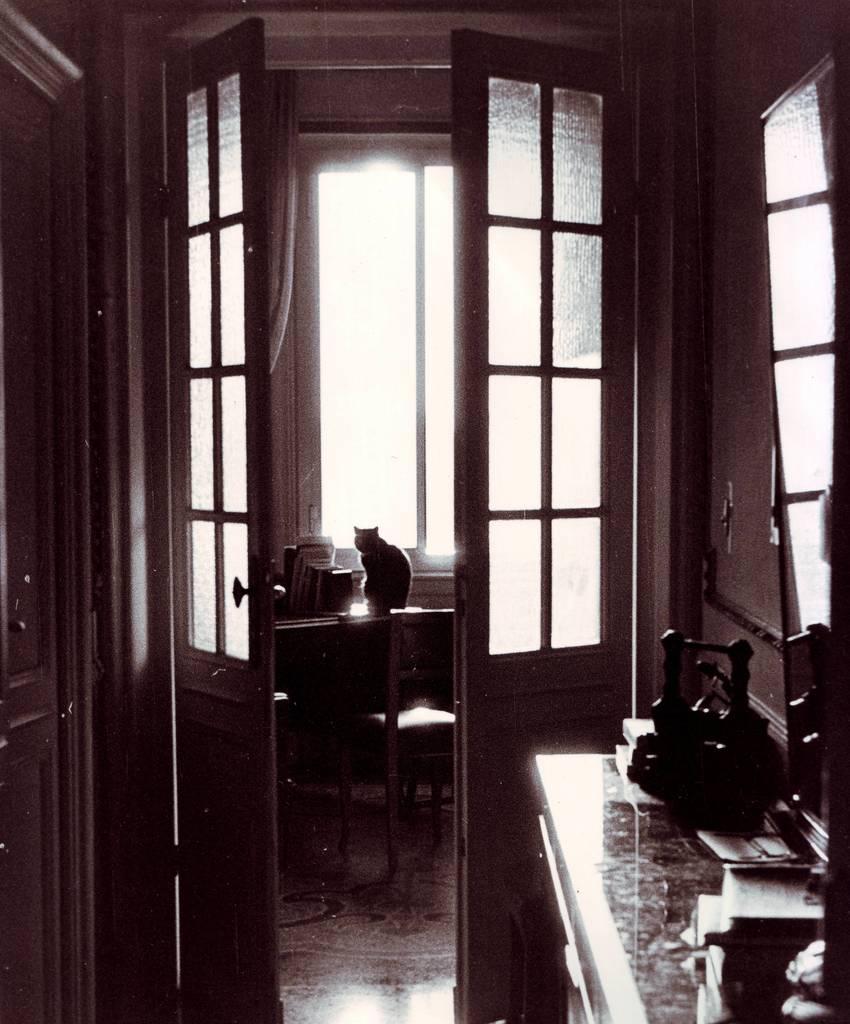Please provide a concise description of this image. In this image I can see in the middle a cat is sitting on the table, there are chairs and here there are doors with glasses. 